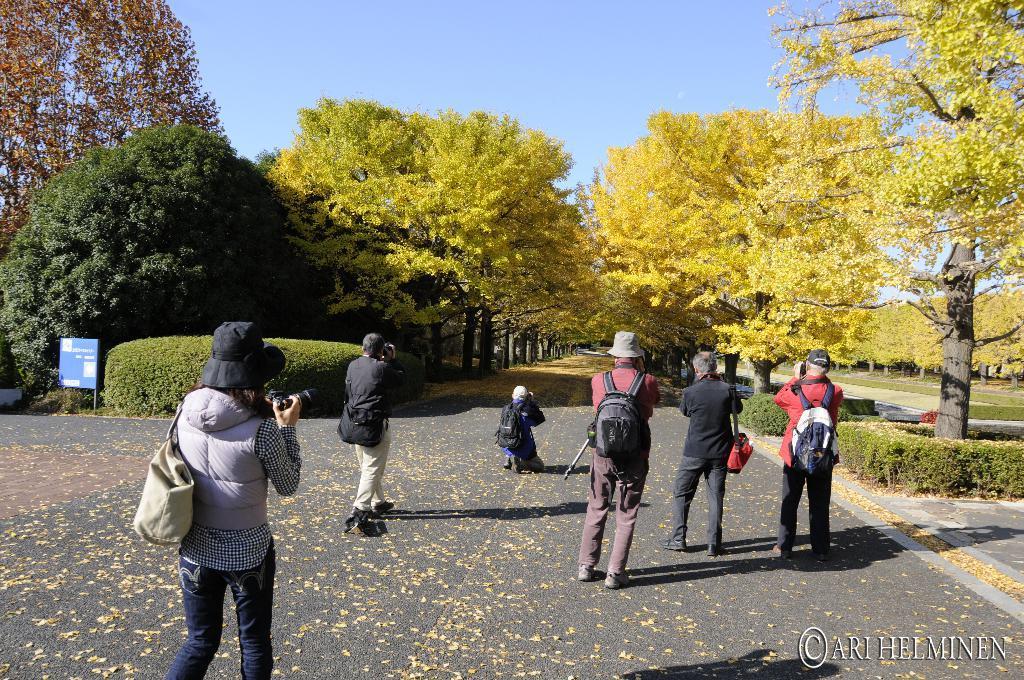Can you describe this image briefly? In this image I can see group of people standing, the person in front wearing gray jacket, blue pant and holding a camera, and I can also see few bags. Background I can see a blue color board, trees in green color and the sky is in blue color. 